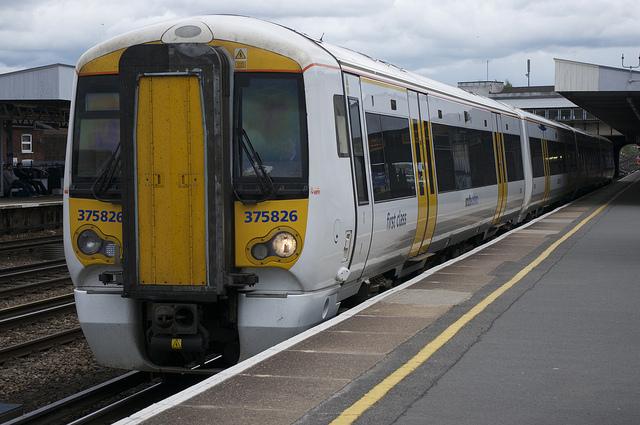Where is this train located?
Be succinct. Station. Is this a subway?
Answer briefly. No. Is this train moving?
Give a very brief answer. Yes. What color is train?
Keep it brief. Yellow and white. Is anyone standing near the train?
Concise answer only. No. 